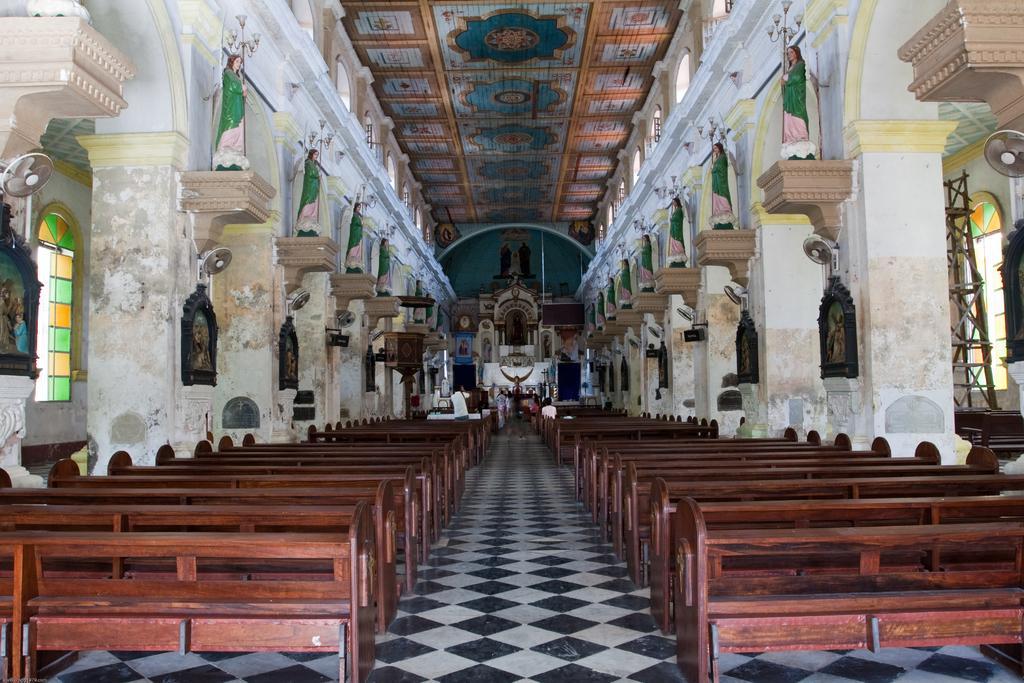Could you give a brief overview of what you see in this image? In this picture there is a way and there are few benches,fans attached to the wall and a sculpture of a person on the wall on either sides of it and there are few people and some other objects in the background. 